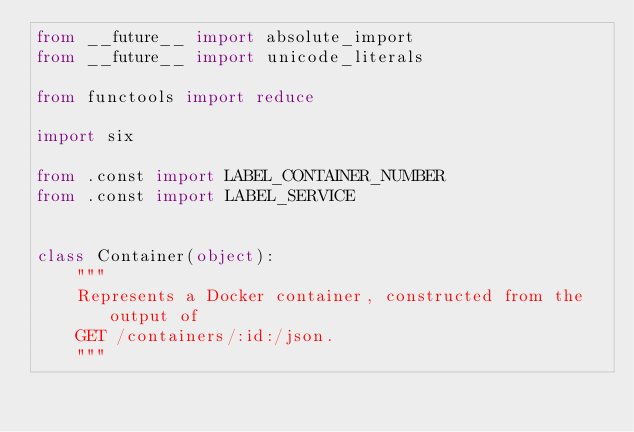<code> <loc_0><loc_0><loc_500><loc_500><_Python_>from __future__ import absolute_import
from __future__ import unicode_literals

from functools import reduce

import six

from .const import LABEL_CONTAINER_NUMBER
from .const import LABEL_SERVICE


class Container(object):
    """
    Represents a Docker container, constructed from the output of
    GET /containers/:id:/json.
    """</code> 